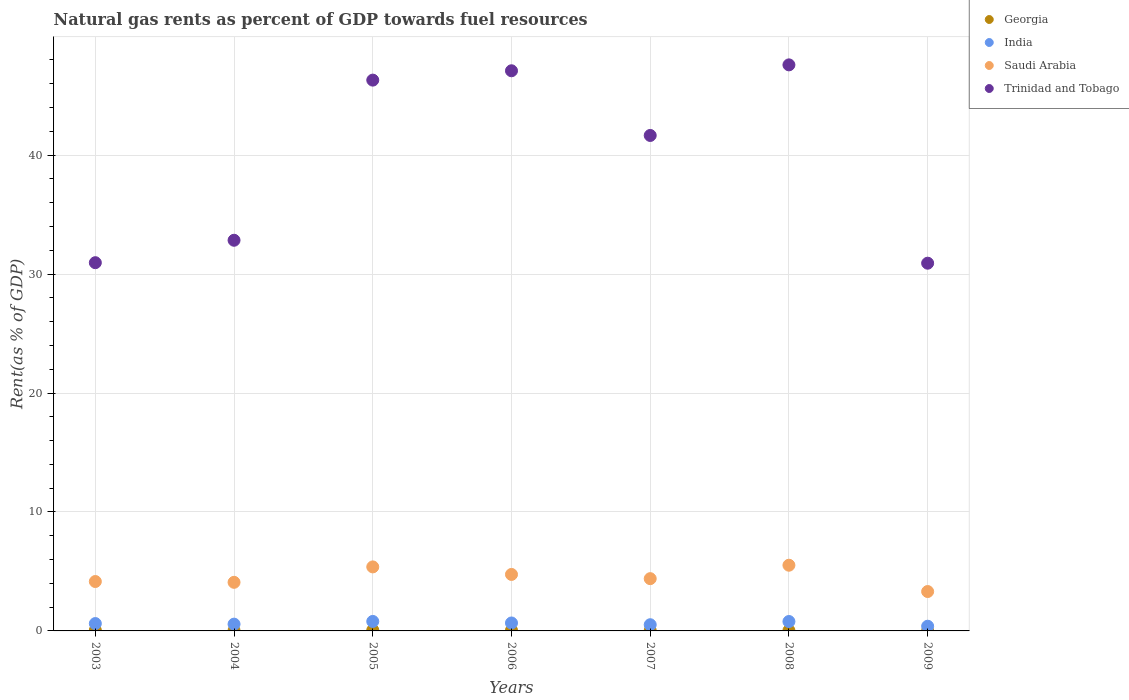Is the number of dotlines equal to the number of legend labels?
Offer a terse response. Yes. What is the matural gas rent in Georgia in 2008?
Provide a short and direct response. 0.03. Across all years, what is the maximum matural gas rent in Saudi Arabia?
Your answer should be compact. 5.52. Across all years, what is the minimum matural gas rent in Saudi Arabia?
Offer a very short reply. 3.31. In which year was the matural gas rent in Saudi Arabia minimum?
Give a very brief answer. 2009. What is the total matural gas rent in Georgia in the graph?
Your answer should be compact. 0.29. What is the difference between the matural gas rent in India in 2005 and that in 2009?
Your answer should be compact. 0.4. What is the difference between the matural gas rent in Georgia in 2006 and the matural gas rent in India in 2009?
Your response must be concise. -0.34. What is the average matural gas rent in Saudi Arabia per year?
Give a very brief answer. 4.51. In the year 2003, what is the difference between the matural gas rent in Saudi Arabia and matural gas rent in Trinidad and Tobago?
Offer a terse response. -26.8. In how many years, is the matural gas rent in Georgia greater than 18 %?
Make the answer very short. 0. What is the ratio of the matural gas rent in Saudi Arabia in 2003 to that in 2008?
Provide a short and direct response. 0.75. What is the difference between the highest and the second highest matural gas rent in Trinidad and Tobago?
Make the answer very short. 0.5. What is the difference between the highest and the lowest matural gas rent in Georgia?
Ensure brevity in your answer.  0.06. In how many years, is the matural gas rent in Georgia greater than the average matural gas rent in Georgia taken over all years?
Your answer should be very brief. 3. Is it the case that in every year, the sum of the matural gas rent in Saudi Arabia and matural gas rent in Trinidad and Tobago  is greater than the sum of matural gas rent in India and matural gas rent in Georgia?
Give a very brief answer. No. Does the matural gas rent in Saudi Arabia monotonically increase over the years?
Make the answer very short. No. Is the matural gas rent in Georgia strictly greater than the matural gas rent in Trinidad and Tobago over the years?
Give a very brief answer. No. Is the matural gas rent in Georgia strictly less than the matural gas rent in Trinidad and Tobago over the years?
Your answer should be compact. Yes. How many dotlines are there?
Ensure brevity in your answer.  4. What is the difference between two consecutive major ticks on the Y-axis?
Offer a very short reply. 10. Are the values on the major ticks of Y-axis written in scientific E-notation?
Your response must be concise. No. Does the graph contain grids?
Your response must be concise. Yes. How many legend labels are there?
Provide a short and direct response. 4. What is the title of the graph?
Ensure brevity in your answer.  Natural gas rents as percent of GDP towards fuel resources. What is the label or title of the Y-axis?
Offer a very short reply. Rent(as % of GDP). What is the Rent(as % of GDP) of Georgia in 2003?
Keep it short and to the point. 0.06. What is the Rent(as % of GDP) of India in 2003?
Provide a succinct answer. 0.62. What is the Rent(as % of GDP) in Saudi Arabia in 2003?
Give a very brief answer. 4.15. What is the Rent(as % of GDP) of Trinidad and Tobago in 2003?
Ensure brevity in your answer.  30.96. What is the Rent(as % of GDP) of Georgia in 2004?
Offer a very short reply. 0.03. What is the Rent(as % of GDP) of India in 2004?
Make the answer very short. 0.57. What is the Rent(as % of GDP) in Saudi Arabia in 2004?
Keep it short and to the point. 4.09. What is the Rent(as % of GDP) of Trinidad and Tobago in 2004?
Provide a short and direct response. 32.84. What is the Rent(as % of GDP) of Georgia in 2005?
Offer a terse response. 0.07. What is the Rent(as % of GDP) in India in 2005?
Your response must be concise. 0.8. What is the Rent(as % of GDP) in Saudi Arabia in 2005?
Keep it short and to the point. 5.38. What is the Rent(as % of GDP) in Trinidad and Tobago in 2005?
Provide a short and direct response. 46.3. What is the Rent(as % of GDP) of Georgia in 2006?
Ensure brevity in your answer.  0.05. What is the Rent(as % of GDP) of India in 2006?
Give a very brief answer. 0.67. What is the Rent(as % of GDP) of Saudi Arabia in 2006?
Your response must be concise. 4.75. What is the Rent(as % of GDP) in Trinidad and Tobago in 2006?
Your response must be concise. 47.09. What is the Rent(as % of GDP) of Georgia in 2007?
Your response must be concise. 0.03. What is the Rent(as % of GDP) in India in 2007?
Offer a very short reply. 0.52. What is the Rent(as % of GDP) in Saudi Arabia in 2007?
Give a very brief answer. 4.39. What is the Rent(as % of GDP) in Trinidad and Tobago in 2007?
Your answer should be very brief. 41.65. What is the Rent(as % of GDP) in Georgia in 2008?
Keep it short and to the point. 0.03. What is the Rent(as % of GDP) of India in 2008?
Make the answer very short. 0.79. What is the Rent(as % of GDP) in Saudi Arabia in 2008?
Provide a succinct answer. 5.52. What is the Rent(as % of GDP) in Trinidad and Tobago in 2008?
Make the answer very short. 47.58. What is the Rent(as % of GDP) of Georgia in 2009?
Your answer should be very brief. 0.01. What is the Rent(as % of GDP) of India in 2009?
Your answer should be very brief. 0.39. What is the Rent(as % of GDP) of Saudi Arabia in 2009?
Your response must be concise. 3.31. What is the Rent(as % of GDP) in Trinidad and Tobago in 2009?
Make the answer very short. 30.91. Across all years, what is the maximum Rent(as % of GDP) in Georgia?
Your response must be concise. 0.07. Across all years, what is the maximum Rent(as % of GDP) in India?
Make the answer very short. 0.8. Across all years, what is the maximum Rent(as % of GDP) in Saudi Arabia?
Keep it short and to the point. 5.52. Across all years, what is the maximum Rent(as % of GDP) in Trinidad and Tobago?
Your answer should be very brief. 47.58. Across all years, what is the minimum Rent(as % of GDP) of Georgia?
Keep it short and to the point. 0.01. Across all years, what is the minimum Rent(as % of GDP) of India?
Make the answer very short. 0.39. Across all years, what is the minimum Rent(as % of GDP) in Saudi Arabia?
Your answer should be compact. 3.31. Across all years, what is the minimum Rent(as % of GDP) in Trinidad and Tobago?
Ensure brevity in your answer.  30.91. What is the total Rent(as % of GDP) in Georgia in the graph?
Your answer should be compact. 0.29. What is the total Rent(as % of GDP) of India in the graph?
Ensure brevity in your answer.  4.36. What is the total Rent(as % of GDP) in Saudi Arabia in the graph?
Make the answer very short. 31.6. What is the total Rent(as % of GDP) in Trinidad and Tobago in the graph?
Keep it short and to the point. 277.33. What is the difference between the Rent(as % of GDP) of Georgia in 2003 and that in 2004?
Offer a terse response. 0.03. What is the difference between the Rent(as % of GDP) in India in 2003 and that in 2004?
Give a very brief answer. 0.05. What is the difference between the Rent(as % of GDP) in Saudi Arabia in 2003 and that in 2004?
Your answer should be very brief. 0.07. What is the difference between the Rent(as % of GDP) in Trinidad and Tobago in 2003 and that in 2004?
Provide a short and direct response. -1.89. What is the difference between the Rent(as % of GDP) in Georgia in 2003 and that in 2005?
Give a very brief answer. -0.01. What is the difference between the Rent(as % of GDP) of India in 2003 and that in 2005?
Your answer should be compact. -0.18. What is the difference between the Rent(as % of GDP) of Saudi Arabia in 2003 and that in 2005?
Offer a terse response. -1.23. What is the difference between the Rent(as % of GDP) in Trinidad and Tobago in 2003 and that in 2005?
Offer a terse response. -15.35. What is the difference between the Rent(as % of GDP) of Georgia in 2003 and that in 2006?
Provide a succinct answer. 0.01. What is the difference between the Rent(as % of GDP) of India in 2003 and that in 2006?
Give a very brief answer. -0.05. What is the difference between the Rent(as % of GDP) of Saudi Arabia in 2003 and that in 2006?
Offer a very short reply. -0.59. What is the difference between the Rent(as % of GDP) of Trinidad and Tobago in 2003 and that in 2006?
Offer a very short reply. -16.13. What is the difference between the Rent(as % of GDP) in Georgia in 2003 and that in 2007?
Your answer should be compact. 0.03. What is the difference between the Rent(as % of GDP) in India in 2003 and that in 2007?
Offer a very short reply. 0.1. What is the difference between the Rent(as % of GDP) in Saudi Arabia in 2003 and that in 2007?
Your response must be concise. -0.24. What is the difference between the Rent(as % of GDP) of Trinidad and Tobago in 2003 and that in 2007?
Make the answer very short. -10.7. What is the difference between the Rent(as % of GDP) of Georgia in 2003 and that in 2008?
Provide a succinct answer. 0.03. What is the difference between the Rent(as % of GDP) in India in 2003 and that in 2008?
Make the answer very short. -0.17. What is the difference between the Rent(as % of GDP) of Saudi Arabia in 2003 and that in 2008?
Ensure brevity in your answer.  -1.37. What is the difference between the Rent(as % of GDP) in Trinidad and Tobago in 2003 and that in 2008?
Give a very brief answer. -16.63. What is the difference between the Rent(as % of GDP) of Georgia in 2003 and that in 2009?
Provide a succinct answer. 0.05. What is the difference between the Rent(as % of GDP) of India in 2003 and that in 2009?
Offer a very short reply. 0.22. What is the difference between the Rent(as % of GDP) of Saudi Arabia in 2003 and that in 2009?
Provide a short and direct response. 0.84. What is the difference between the Rent(as % of GDP) of Trinidad and Tobago in 2003 and that in 2009?
Your response must be concise. 0.04. What is the difference between the Rent(as % of GDP) of Georgia in 2004 and that in 2005?
Offer a terse response. -0.03. What is the difference between the Rent(as % of GDP) in India in 2004 and that in 2005?
Your answer should be compact. -0.23. What is the difference between the Rent(as % of GDP) in Saudi Arabia in 2004 and that in 2005?
Your answer should be very brief. -1.3. What is the difference between the Rent(as % of GDP) of Trinidad and Tobago in 2004 and that in 2005?
Give a very brief answer. -13.46. What is the difference between the Rent(as % of GDP) of Georgia in 2004 and that in 2006?
Keep it short and to the point. -0.02. What is the difference between the Rent(as % of GDP) of India in 2004 and that in 2006?
Offer a terse response. -0.1. What is the difference between the Rent(as % of GDP) in Saudi Arabia in 2004 and that in 2006?
Your response must be concise. -0.66. What is the difference between the Rent(as % of GDP) in Trinidad and Tobago in 2004 and that in 2006?
Your response must be concise. -14.25. What is the difference between the Rent(as % of GDP) of Georgia in 2004 and that in 2007?
Keep it short and to the point. -0. What is the difference between the Rent(as % of GDP) of India in 2004 and that in 2007?
Make the answer very short. 0.05. What is the difference between the Rent(as % of GDP) in Saudi Arabia in 2004 and that in 2007?
Offer a terse response. -0.31. What is the difference between the Rent(as % of GDP) in Trinidad and Tobago in 2004 and that in 2007?
Keep it short and to the point. -8.81. What is the difference between the Rent(as % of GDP) of India in 2004 and that in 2008?
Keep it short and to the point. -0.22. What is the difference between the Rent(as % of GDP) of Saudi Arabia in 2004 and that in 2008?
Provide a succinct answer. -1.44. What is the difference between the Rent(as % of GDP) of Trinidad and Tobago in 2004 and that in 2008?
Give a very brief answer. -14.74. What is the difference between the Rent(as % of GDP) in Georgia in 2004 and that in 2009?
Give a very brief answer. 0.02. What is the difference between the Rent(as % of GDP) in India in 2004 and that in 2009?
Keep it short and to the point. 0.18. What is the difference between the Rent(as % of GDP) in Saudi Arabia in 2004 and that in 2009?
Your response must be concise. 0.77. What is the difference between the Rent(as % of GDP) in Trinidad and Tobago in 2004 and that in 2009?
Offer a very short reply. 1.93. What is the difference between the Rent(as % of GDP) of Georgia in 2005 and that in 2006?
Make the answer very short. 0.01. What is the difference between the Rent(as % of GDP) in India in 2005 and that in 2006?
Ensure brevity in your answer.  0.13. What is the difference between the Rent(as % of GDP) of Saudi Arabia in 2005 and that in 2006?
Offer a terse response. 0.63. What is the difference between the Rent(as % of GDP) in Trinidad and Tobago in 2005 and that in 2006?
Your response must be concise. -0.79. What is the difference between the Rent(as % of GDP) in Georgia in 2005 and that in 2007?
Ensure brevity in your answer.  0.03. What is the difference between the Rent(as % of GDP) of India in 2005 and that in 2007?
Keep it short and to the point. 0.28. What is the difference between the Rent(as % of GDP) in Saudi Arabia in 2005 and that in 2007?
Your response must be concise. 0.99. What is the difference between the Rent(as % of GDP) in Trinidad and Tobago in 2005 and that in 2007?
Offer a terse response. 4.65. What is the difference between the Rent(as % of GDP) of Georgia in 2005 and that in 2008?
Ensure brevity in your answer.  0.03. What is the difference between the Rent(as % of GDP) of India in 2005 and that in 2008?
Keep it short and to the point. 0.01. What is the difference between the Rent(as % of GDP) in Saudi Arabia in 2005 and that in 2008?
Provide a succinct answer. -0.14. What is the difference between the Rent(as % of GDP) of Trinidad and Tobago in 2005 and that in 2008?
Keep it short and to the point. -1.28. What is the difference between the Rent(as % of GDP) of Georgia in 2005 and that in 2009?
Keep it short and to the point. 0.06. What is the difference between the Rent(as % of GDP) of India in 2005 and that in 2009?
Ensure brevity in your answer.  0.4. What is the difference between the Rent(as % of GDP) of Saudi Arabia in 2005 and that in 2009?
Make the answer very short. 2.07. What is the difference between the Rent(as % of GDP) of Trinidad and Tobago in 2005 and that in 2009?
Offer a terse response. 15.39. What is the difference between the Rent(as % of GDP) in Georgia in 2006 and that in 2007?
Provide a succinct answer. 0.02. What is the difference between the Rent(as % of GDP) in India in 2006 and that in 2007?
Your response must be concise. 0.15. What is the difference between the Rent(as % of GDP) of Saudi Arabia in 2006 and that in 2007?
Offer a very short reply. 0.35. What is the difference between the Rent(as % of GDP) in Trinidad and Tobago in 2006 and that in 2007?
Your answer should be compact. 5.44. What is the difference between the Rent(as % of GDP) in Georgia in 2006 and that in 2008?
Your answer should be compact. 0.02. What is the difference between the Rent(as % of GDP) of India in 2006 and that in 2008?
Ensure brevity in your answer.  -0.12. What is the difference between the Rent(as % of GDP) in Saudi Arabia in 2006 and that in 2008?
Offer a very short reply. -0.77. What is the difference between the Rent(as % of GDP) of Trinidad and Tobago in 2006 and that in 2008?
Make the answer very short. -0.5. What is the difference between the Rent(as % of GDP) of Georgia in 2006 and that in 2009?
Make the answer very short. 0.04. What is the difference between the Rent(as % of GDP) in India in 2006 and that in 2009?
Your answer should be compact. 0.27. What is the difference between the Rent(as % of GDP) in Saudi Arabia in 2006 and that in 2009?
Give a very brief answer. 1.44. What is the difference between the Rent(as % of GDP) of Trinidad and Tobago in 2006 and that in 2009?
Make the answer very short. 16.18. What is the difference between the Rent(as % of GDP) of Georgia in 2007 and that in 2008?
Provide a short and direct response. 0. What is the difference between the Rent(as % of GDP) of India in 2007 and that in 2008?
Provide a succinct answer. -0.27. What is the difference between the Rent(as % of GDP) of Saudi Arabia in 2007 and that in 2008?
Offer a very short reply. -1.13. What is the difference between the Rent(as % of GDP) of Trinidad and Tobago in 2007 and that in 2008?
Provide a short and direct response. -5.93. What is the difference between the Rent(as % of GDP) of Georgia in 2007 and that in 2009?
Your response must be concise. 0.02. What is the difference between the Rent(as % of GDP) of India in 2007 and that in 2009?
Offer a very short reply. 0.13. What is the difference between the Rent(as % of GDP) in Saudi Arabia in 2007 and that in 2009?
Ensure brevity in your answer.  1.08. What is the difference between the Rent(as % of GDP) in Trinidad and Tobago in 2007 and that in 2009?
Your answer should be compact. 10.74. What is the difference between the Rent(as % of GDP) of Georgia in 2008 and that in 2009?
Offer a very short reply. 0.02. What is the difference between the Rent(as % of GDP) in India in 2008 and that in 2009?
Your response must be concise. 0.4. What is the difference between the Rent(as % of GDP) in Saudi Arabia in 2008 and that in 2009?
Offer a terse response. 2.21. What is the difference between the Rent(as % of GDP) of Trinidad and Tobago in 2008 and that in 2009?
Your answer should be very brief. 16.67. What is the difference between the Rent(as % of GDP) in Georgia in 2003 and the Rent(as % of GDP) in India in 2004?
Keep it short and to the point. -0.51. What is the difference between the Rent(as % of GDP) of Georgia in 2003 and the Rent(as % of GDP) of Saudi Arabia in 2004?
Ensure brevity in your answer.  -4.03. What is the difference between the Rent(as % of GDP) of Georgia in 2003 and the Rent(as % of GDP) of Trinidad and Tobago in 2004?
Your answer should be very brief. -32.78. What is the difference between the Rent(as % of GDP) of India in 2003 and the Rent(as % of GDP) of Saudi Arabia in 2004?
Your response must be concise. -3.47. What is the difference between the Rent(as % of GDP) of India in 2003 and the Rent(as % of GDP) of Trinidad and Tobago in 2004?
Your answer should be very brief. -32.22. What is the difference between the Rent(as % of GDP) of Saudi Arabia in 2003 and the Rent(as % of GDP) of Trinidad and Tobago in 2004?
Ensure brevity in your answer.  -28.69. What is the difference between the Rent(as % of GDP) of Georgia in 2003 and the Rent(as % of GDP) of India in 2005?
Keep it short and to the point. -0.74. What is the difference between the Rent(as % of GDP) in Georgia in 2003 and the Rent(as % of GDP) in Saudi Arabia in 2005?
Your answer should be compact. -5.32. What is the difference between the Rent(as % of GDP) of Georgia in 2003 and the Rent(as % of GDP) of Trinidad and Tobago in 2005?
Your answer should be compact. -46.24. What is the difference between the Rent(as % of GDP) in India in 2003 and the Rent(as % of GDP) in Saudi Arabia in 2005?
Offer a terse response. -4.76. What is the difference between the Rent(as % of GDP) of India in 2003 and the Rent(as % of GDP) of Trinidad and Tobago in 2005?
Your answer should be compact. -45.68. What is the difference between the Rent(as % of GDP) in Saudi Arabia in 2003 and the Rent(as % of GDP) in Trinidad and Tobago in 2005?
Give a very brief answer. -42.15. What is the difference between the Rent(as % of GDP) of Georgia in 2003 and the Rent(as % of GDP) of India in 2006?
Give a very brief answer. -0.61. What is the difference between the Rent(as % of GDP) of Georgia in 2003 and the Rent(as % of GDP) of Saudi Arabia in 2006?
Provide a short and direct response. -4.69. What is the difference between the Rent(as % of GDP) in Georgia in 2003 and the Rent(as % of GDP) in Trinidad and Tobago in 2006?
Your response must be concise. -47.03. What is the difference between the Rent(as % of GDP) in India in 2003 and the Rent(as % of GDP) in Saudi Arabia in 2006?
Make the answer very short. -4.13. What is the difference between the Rent(as % of GDP) of India in 2003 and the Rent(as % of GDP) of Trinidad and Tobago in 2006?
Your answer should be compact. -46.47. What is the difference between the Rent(as % of GDP) in Saudi Arabia in 2003 and the Rent(as % of GDP) in Trinidad and Tobago in 2006?
Your response must be concise. -42.93. What is the difference between the Rent(as % of GDP) of Georgia in 2003 and the Rent(as % of GDP) of India in 2007?
Make the answer very short. -0.46. What is the difference between the Rent(as % of GDP) in Georgia in 2003 and the Rent(as % of GDP) in Saudi Arabia in 2007?
Your response must be concise. -4.33. What is the difference between the Rent(as % of GDP) in Georgia in 2003 and the Rent(as % of GDP) in Trinidad and Tobago in 2007?
Give a very brief answer. -41.59. What is the difference between the Rent(as % of GDP) in India in 2003 and the Rent(as % of GDP) in Saudi Arabia in 2007?
Offer a very short reply. -3.78. What is the difference between the Rent(as % of GDP) in India in 2003 and the Rent(as % of GDP) in Trinidad and Tobago in 2007?
Make the answer very short. -41.03. What is the difference between the Rent(as % of GDP) in Saudi Arabia in 2003 and the Rent(as % of GDP) in Trinidad and Tobago in 2007?
Keep it short and to the point. -37.5. What is the difference between the Rent(as % of GDP) of Georgia in 2003 and the Rent(as % of GDP) of India in 2008?
Provide a succinct answer. -0.73. What is the difference between the Rent(as % of GDP) of Georgia in 2003 and the Rent(as % of GDP) of Saudi Arabia in 2008?
Your answer should be very brief. -5.46. What is the difference between the Rent(as % of GDP) in Georgia in 2003 and the Rent(as % of GDP) in Trinidad and Tobago in 2008?
Your answer should be compact. -47.52. What is the difference between the Rent(as % of GDP) of India in 2003 and the Rent(as % of GDP) of Saudi Arabia in 2008?
Provide a succinct answer. -4.9. What is the difference between the Rent(as % of GDP) of India in 2003 and the Rent(as % of GDP) of Trinidad and Tobago in 2008?
Your answer should be compact. -46.97. What is the difference between the Rent(as % of GDP) in Saudi Arabia in 2003 and the Rent(as % of GDP) in Trinidad and Tobago in 2008?
Ensure brevity in your answer.  -43.43. What is the difference between the Rent(as % of GDP) in Georgia in 2003 and the Rent(as % of GDP) in India in 2009?
Offer a terse response. -0.33. What is the difference between the Rent(as % of GDP) of Georgia in 2003 and the Rent(as % of GDP) of Saudi Arabia in 2009?
Offer a very short reply. -3.25. What is the difference between the Rent(as % of GDP) in Georgia in 2003 and the Rent(as % of GDP) in Trinidad and Tobago in 2009?
Make the answer very short. -30.85. What is the difference between the Rent(as % of GDP) of India in 2003 and the Rent(as % of GDP) of Saudi Arabia in 2009?
Provide a short and direct response. -2.69. What is the difference between the Rent(as % of GDP) of India in 2003 and the Rent(as % of GDP) of Trinidad and Tobago in 2009?
Your answer should be very brief. -30.29. What is the difference between the Rent(as % of GDP) in Saudi Arabia in 2003 and the Rent(as % of GDP) in Trinidad and Tobago in 2009?
Provide a succinct answer. -26.76. What is the difference between the Rent(as % of GDP) of Georgia in 2004 and the Rent(as % of GDP) of India in 2005?
Your answer should be compact. -0.77. What is the difference between the Rent(as % of GDP) of Georgia in 2004 and the Rent(as % of GDP) of Saudi Arabia in 2005?
Make the answer very short. -5.35. What is the difference between the Rent(as % of GDP) of Georgia in 2004 and the Rent(as % of GDP) of Trinidad and Tobago in 2005?
Your answer should be compact. -46.27. What is the difference between the Rent(as % of GDP) in India in 2004 and the Rent(as % of GDP) in Saudi Arabia in 2005?
Give a very brief answer. -4.81. What is the difference between the Rent(as % of GDP) in India in 2004 and the Rent(as % of GDP) in Trinidad and Tobago in 2005?
Offer a terse response. -45.73. What is the difference between the Rent(as % of GDP) of Saudi Arabia in 2004 and the Rent(as % of GDP) of Trinidad and Tobago in 2005?
Make the answer very short. -42.22. What is the difference between the Rent(as % of GDP) in Georgia in 2004 and the Rent(as % of GDP) in India in 2006?
Ensure brevity in your answer.  -0.64. What is the difference between the Rent(as % of GDP) of Georgia in 2004 and the Rent(as % of GDP) of Saudi Arabia in 2006?
Your answer should be compact. -4.72. What is the difference between the Rent(as % of GDP) in Georgia in 2004 and the Rent(as % of GDP) in Trinidad and Tobago in 2006?
Your answer should be compact. -47.06. What is the difference between the Rent(as % of GDP) of India in 2004 and the Rent(as % of GDP) of Saudi Arabia in 2006?
Your response must be concise. -4.18. What is the difference between the Rent(as % of GDP) of India in 2004 and the Rent(as % of GDP) of Trinidad and Tobago in 2006?
Provide a succinct answer. -46.52. What is the difference between the Rent(as % of GDP) in Saudi Arabia in 2004 and the Rent(as % of GDP) in Trinidad and Tobago in 2006?
Make the answer very short. -43. What is the difference between the Rent(as % of GDP) of Georgia in 2004 and the Rent(as % of GDP) of India in 2007?
Offer a terse response. -0.49. What is the difference between the Rent(as % of GDP) of Georgia in 2004 and the Rent(as % of GDP) of Saudi Arabia in 2007?
Your answer should be very brief. -4.36. What is the difference between the Rent(as % of GDP) of Georgia in 2004 and the Rent(as % of GDP) of Trinidad and Tobago in 2007?
Keep it short and to the point. -41.62. What is the difference between the Rent(as % of GDP) in India in 2004 and the Rent(as % of GDP) in Saudi Arabia in 2007?
Ensure brevity in your answer.  -3.82. What is the difference between the Rent(as % of GDP) of India in 2004 and the Rent(as % of GDP) of Trinidad and Tobago in 2007?
Keep it short and to the point. -41.08. What is the difference between the Rent(as % of GDP) in Saudi Arabia in 2004 and the Rent(as % of GDP) in Trinidad and Tobago in 2007?
Offer a terse response. -37.57. What is the difference between the Rent(as % of GDP) in Georgia in 2004 and the Rent(as % of GDP) in India in 2008?
Offer a terse response. -0.76. What is the difference between the Rent(as % of GDP) in Georgia in 2004 and the Rent(as % of GDP) in Saudi Arabia in 2008?
Ensure brevity in your answer.  -5.49. What is the difference between the Rent(as % of GDP) of Georgia in 2004 and the Rent(as % of GDP) of Trinidad and Tobago in 2008?
Make the answer very short. -47.55. What is the difference between the Rent(as % of GDP) in India in 2004 and the Rent(as % of GDP) in Saudi Arabia in 2008?
Provide a short and direct response. -4.95. What is the difference between the Rent(as % of GDP) in India in 2004 and the Rent(as % of GDP) in Trinidad and Tobago in 2008?
Provide a short and direct response. -47.01. What is the difference between the Rent(as % of GDP) of Saudi Arabia in 2004 and the Rent(as % of GDP) of Trinidad and Tobago in 2008?
Provide a short and direct response. -43.5. What is the difference between the Rent(as % of GDP) of Georgia in 2004 and the Rent(as % of GDP) of India in 2009?
Keep it short and to the point. -0.36. What is the difference between the Rent(as % of GDP) in Georgia in 2004 and the Rent(as % of GDP) in Saudi Arabia in 2009?
Offer a very short reply. -3.28. What is the difference between the Rent(as % of GDP) in Georgia in 2004 and the Rent(as % of GDP) in Trinidad and Tobago in 2009?
Provide a succinct answer. -30.88. What is the difference between the Rent(as % of GDP) in India in 2004 and the Rent(as % of GDP) in Saudi Arabia in 2009?
Provide a succinct answer. -2.74. What is the difference between the Rent(as % of GDP) of India in 2004 and the Rent(as % of GDP) of Trinidad and Tobago in 2009?
Keep it short and to the point. -30.34. What is the difference between the Rent(as % of GDP) in Saudi Arabia in 2004 and the Rent(as % of GDP) in Trinidad and Tobago in 2009?
Provide a short and direct response. -26.83. What is the difference between the Rent(as % of GDP) in Georgia in 2005 and the Rent(as % of GDP) in India in 2006?
Your response must be concise. -0.6. What is the difference between the Rent(as % of GDP) in Georgia in 2005 and the Rent(as % of GDP) in Saudi Arabia in 2006?
Your answer should be very brief. -4.68. What is the difference between the Rent(as % of GDP) in Georgia in 2005 and the Rent(as % of GDP) in Trinidad and Tobago in 2006?
Provide a short and direct response. -47.02. What is the difference between the Rent(as % of GDP) of India in 2005 and the Rent(as % of GDP) of Saudi Arabia in 2006?
Your answer should be very brief. -3.95. What is the difference between the Rent(as % of GDP) of India in 2005 and the Rent(as % of GDP) of Trinidad and Tobago in 2006?
Make the answer very short. -46.29. What is the difference between the Rent(as % of GDP) in Saudi Arabia in 2005 and the Rent(as % of GDP) in Trinidad and Tobago in 2006?
Your response must be concise. -41.71. What is the difference between the Rent(as % of GDP) of Georgia in 2005 and the Rent(as % of GDP) of India in 2007?
Make the answer very short. -0.46. What is the difference between the Rent(as % of GDP) of Georgia in 2005 and the Rent(as % of GDP) of Saudi Arabia in 2007?
Keep it short and to the point. -4.33. What is the difference between the Rent(as % of GDP) of Georgia in 2005 and the Rent(as % of GDP) of Trinidad and Tobago in 2007?
Keep it short and to the point. -41.59. What is the difference between the Rent(as % of GDP) in India in 2005 and the Rent(as % of GDP) in Saudi Arabia in 2007?
Your response must be concise. -3.6. What is the difference between the Rent(as % of GDP) of India in 2005 and the Rent(as % of GDP) of Trinidad and Tobago in 2007?
Provide a short and direct response. -40.85. What is the difference between the Rent(as % of GDP) in Saudi Arabia in 2005 and the Rent(as % of GDP) in Trinidad and Tobago in 2007?
Offer a very short reply. -36.27. What is the difference between the Rent(as % of GDP) in Georgia in 2005 and the Rent(as % of GDP) in India in 2008?
Your response must be concise. -0.73. What is the difference between the Rent(as % of GDP) of Georgia in 2005 and the Rent(as % of GDP) of Saudi Arabia in 2008?
Keep it short and to the point. -5.46. What is the difference between the Rent(as % of GDP) of Georgia in 2005 and the Rent(as % of GDP) of Trinidad and Tobago in 2008?
Your answer should be very brief. -47.52. What is the difference between the Rent(as % of GDP) of India in 2005 and the Rent(as % of GDP) of Saudi Arabia in 2008?
Give a very brief answer. -4.73. What is the difference between the Rent(as % of GDP) in India in 2005 and the Rent(as % of GDP) in Trinidad and Tobago in 2008?
Ensure brevity in your answer.  -46.79. What is the difference between the Rent(as % of GDP) of Saudi Arabia in 2005 and the Rent(as % of GDP) of Trinidad and Tobago in 2008?
Provide a succinct answer. -42.2. What is the difference between the Rent(as % of GDP) in Georgia in 2005 and the Rent(as % of GDP) in India in 2009?
Provide a succinct answer. -0.33. What is the difference between the Rent(as % of GDP) in Georgia in 2005 and the Rent(as % of GDP) in Saudi Arabia in 2009?
Give a very brief answer. -3.25. What is the difference between the Rent(as % of GDP) in Georgia in 2005 and the Rent(as % of GDP) in Trinidad and Tobago in 2009?
Offer a terse response. -30.85. What is the difference between the Rent(as % of GDP) of India in 2005 and the Rent(as % of GDP) of Saudi Arabia in 2009?
Your response must be concise. -2.51. What is the difference between the Rent(as % of GDP) of India in 2005 and the Rent(as % of GDP) of Trinidad and Tobago in 2009?
Provide a short and direct response. -30.11. What is the difference between the Rent(as % of GDP) of Saudi Arabia in 2005 and the Rent(as % of GDP) of Trinidad and Tobago in 2009?
Your answer should be compact. -25.53. What is the difference between the Rent(as % of GDP) of Georgia in 2006 and the Rent(as % of GDP) of India in 2007?
Your answer should be compact. -0.47. What is the difference between the Rent(as % of GDP) in Georgia in 2006 and the Rent(as % of GDP) in Saudi Arabia in 2007?
Ensure brevity in your answer.  -4.34. What is the difference between the Rent(as % of GDP) in Georgia in 2006 and the Rent(as % of GDP) in Trinidad and Tobago in 2007?
Your answer should be compact. -41.6. What is the difference between the Rent(as % of GDP) of India in 2006 and the Rent(as % of GDP) of Saudi Arabia in 2007?
Provide a succinct answer. -3.73. What is the difference between the Rent(as % of GDP) of India in 2006 and the Rent(as % of GDP) of Trinidad and Tobago in 2007?
Your answer should be compact. -40.98. What is the difference between the Rent(as % of GDP) of Saudi Arabia in 2006 and the Rent(as % of GDP) of Trinidad and Tobago in 2007?
Keep it short and to the point. -36.9. What is the difference between the Rent(as % of GDP) of Georgia in 2006 and the Rent(as % of GDP) of India in 2008?
Ensure brevity in your answer.  -0.74. What is the difference between the Rent(as % of GDP) of Georgia in 2006 and the Rent(as % of GDP) of Saudi Arabia in 2008?
Offer a very short reply. -5.47. What is the difference between the Rent(as % of GDP) of Georgia in 2006 and the Rent(as % of GDP) of Trinidad and Tobago in 2008?
Offer a very short reply. -47.53. What is the difference between the Rent(as % of GDP) in India in 2006 and the Rent(as % of GDP) in Saudi Arabia in 2008?
Your response must be concise. -4.86. What is the difference between the Rent(as % of GDP) of India in 2006 and the Rent(as % of GDP) of Trinidad and Tobago in 2008?
Offer a terse response. -46.92. What is the difference between the Rent(as % of GDP) of Saudi Arabia in 2006 and the Rent(as % of GDP) of Trinidad and Tobago in 2008?
Your answer should be compact. -42.84. What is the difference between the Rent(as % of GDP) in Georgia in 2006 and the Rent(as % of GDP) in India in 2009?
Provide a short and direct response. -0.34. What is the difference between the Rent(as % of GDP) of Georgia in 2006 and the Rent(as % of GDP) of Saudi Arabia in 2009?
Provide a succinct answer. -3.26. What is the difference between the Rent(as % of GDP) of Georgia in 2006 and the Rent(as % of GDP) of Trinidad and Tobago in 2009?
Make the answer very short. -30.86. What is the difference between the Rent(as % of GDP) of India in 2006 and the Rent(as % of GDP) of Saudi Arabia in 2009?
Offer a terse response. -2.64. What is the difference between the Rent(as % of GDP) of India in 2006 and the Rent(as % of GDP) of Trinidad and Tobago in 2009?
Provide a short and direct response. -30.25. What is the difference between the Rent(as % of GDP) of Saudi Arabia in 2006 and the Rent(as % of GDP) of Trinidad and Tobago in 2009?
Your response must be concise. -26.16. What is the difference between the Rent(as % of GDP) in Georgia in 2007 and the Rent(as % of GDP) in India in 2008?
Your response must be concise. -0.76. What is the difference between the Rent(as % of GDP) in Georgia in 2007 and the Rent(as % of GDP) in Saudi Arabia in 2008?
Make the answer very short. -5.49. What is the difference between the Rent(as % of GDP) in Georgia in 2007 and the Rent(as % of GDP) in Trinidad and Tobago in 2008?
Offer a terse response. -47.55. What is the difference between the Rent(as % of GDP) in India in 2007 and the Rent(as % of GDP) in Saudi Arabia in 2008?
Provide a succinct answer. -5. What is the difference between the Rent(as % of GDP) of India in 2007 and the Rent(as % of GDP) of Trinidad and Tobago in 2008?
Your response must be concise. -47.06. What is the difference between the Rent(as % of GDP) in Saudi Arabia in 2007 and the Rent(as % of GDP) in Trinidad and Tobago in 2008?
Your answer should be very brief. -43.19. What is the difference between the Rent(as % of GDP) of Georgia in 2007 and the Rent(as % of GDP) of India in 2009?
Keep it short and to the point. -0.36. What is the difference between the Rent(as % of GDP) in Georgia in 2007 and the Rent(as % of GDP) in Saudi Arabia in 2009?
Your response must be concise. -3.28. What is the difference between the Rent(as % of GDP) of Georgia in 2007 and the Rent(as % of GDP) of Trinidad and Tobago in 2009?
Provide a short and direct response. -30.88. What is the difference between the Rent(as % of GDP) of India in 2007 and the Rent(as % of GDP) of Saudi Arabia in 2009?
Your response must be concise. -2.79. What is the difference between the Rent(as % of GDP) of India in 2007 and the Rent(as % of GDP) of Trinidad and Tobago in 2009?
Your response must be concise. -30.39. What is the difference between the Rent(as % of GDP) of Saudi Arabia in 2007 and the Rent(as % of GDP) of Trinidad and Tobago in 2009?
Provide a short and direct response. -26.52. What is the difference between the Rent(as % of GDP) in Georgia in 2008 and the Rent(as % of GDP) in India in 2009?
Your answer should be compact. -0.36. What is the difference between the Rent(as % of GDP) of Georgia in 2008 and the Rent(as % of GDP) of Saudi Arabia in 2009?
Make the answer very short. -3.28. What is the difference between the Rent(as % of GDP) of Georgia in 2008 and the Rent(as % of GDP) of Trinidad and Tobago in 2009?
Make the answer very short. -30.88. What is the difference between the Rent(as % of GDP) of India in 2008 and the Rent(as % of GDP) of Saudi Arabia in 2009?
Keep it short and to the point. -2.52. What is the difference between the Rent(as % of GDP) in India in 2008 and the Rent(as % of GDP) in Trinidad and Tobago in 2009?
Offer a very short reply. -30.12. What is the difference between the Rent(as % of GDP) of Saudi Arabia in 2008 and the Rent(as % of GDP) of Trinidad and Tobago in 2009?
Ensure brevity in your answer.  -25.39. What is the average Rent(as % of GDP) of Georgia per year?
Provide a short and direct response. 0.04. What is the average Rent(as % of GDP) in India per year?
Provide a succinct answer. 0.62. What is the average Rent(as % of GDP) of Saudi Arabia per year?
Offer a terse response. 4.51. What is the average Rent(as % of GDP) of Trinidad and Tobago per year?
Offer a terse response. 39.62. In the year 2003, what is the difference between the Rent(as % of GDP) of Georgia and Rent(as % of GDP) of India?
Make the answer very short. -0.56. In the year 2003, what is the difference between the Rent(as % of GDP) in Georgia and Rent(as % of GDP) in Saudi Arabia?
Make the answer very short. -4.09. In the year 2003, what is the difference between the Rent(as % of GDP) in Georgia and Rent(as % of GDP) in Trinidad and Tobago?
Your response must be concise. -30.9. In the year 2003, what is the difference between the Rent(as % of GDP) in India and Rent(as % of GDP) in Saudi Arabia?
Offer a very short reply. -3.54. In the year 2003, what is the difference between the Rent(as % of GDP) in India and Rent(as % of GDP) in Trinidad and Tobago?
Offer a terse response. -30.34. In the year 2003, what is the difference between the Rent(as % of GDP) in Saudi Arabia and Rent(as % of GDP) in Trinidad and Tobago?
Your answer should be compact. -26.8. In the year 2004, what is the difference between the Rent(as % of GDP) in Georgia and Rent(as % of GDP) in India?
Your response must be concise. -0.54. In the year 2004, what is the difference between the Rent(as % of GDP) of Georgia and Rent(as % of GDP) of Saudi Arabia?
Your answer should be very brief. -4.05. In the year 2004, what is the difference between the Rent(as % of GDP) in Georgia and Rent(as % of GDP) in Trinidad and Tobago?
Your answer should be very brief. -32.81. In the year 2004, what is the difference between the Rent(as % of GDP) in India and Rent(as % of GDP) in Saudi Arabia?
Keep it short and to the point. -3.51. In the year 2004, what is the difference between the Rent(as % of GDP) in India and Rent(as % of GDP) in Trinidad and Tobago?
Make the answer very short. -32.27. In the year 2004, what is the difference between the Rent(as % of GDP) of Saudi Arabia and Rent(as % of GDP) of Trinidad and Tobago?
Provide a succinct answer. -28.76. In the year 2005, what is the difference between the Rent(as % of GDP) in Georgia and Rent(as % of GDP) in India?
Offer a terse response. -0.73. In the year 2005, what is the difference between the Rent(as % of GDP) of Georgia and Rent(as % of GDP) of Saudi Arabia?
Ensure brevity in your answer.  -5.32. In the year 2005, what is the difference between the Rent(as % of GDP) in Georgia and Rent(as % of GDP) in Trinidad and Tobago?
Your response must be concise. -46.24. In the year 2005, what is the difference between the Rent(as % of GDP) in India and Rent(as % of GDP) in Saudi Arabia?
Provide a short and direct response. -4.58. In the year 2005, what is the difference between the Rent(as % of GDP) of India and Rent(as % of GDP) of Trinidad and Tobago?
Provide a short and direct response. -45.5. In the year 2005, what is the difference between the Rent(as % of GDP) in Saudi Arabia and Rent(as % of GDP) in Trinidad and Tobago?
Keep it short and to the point. -40.92. In the year 2006, what is the difference between the Rent(as % of GDP) of Georgia and Rent(as % of GDP) of India?
Your response must be concise. -0.62. In the year 2006, what is the difference between the Rent(as % of GDP) in Georgia and Rent(as % of GDP) in Saudi Arabia?
Give a very brief answer. -4.7. In the year 2006, what is the difference between the Rent(as % of GDP) in Georgia and Rent(as % of GDP) in Trinidad and Tobago?
Make the answer very short. -47.04. In the year 2006, what is the difference between the Rent(as % of GDP) in India and Rent(as % of GDP) in Saudi Arabia?
Your answer should be very brief. -4.08. In the year 2006, what is the difference between the Rent(as % of GDP) of India and Rent(as % of GDP) of Trinidad and Tobago?
Your answer should be very brief. -46.42. In the year 2006, what is the difference between the Rent(as % of GDP) of Saudi Arabia and Rent(as % of GDP) of Trinidad and Tobago?
Your answer should be very brief. -42.34. In the year 2007, what is the difference between the Rent(as % of GDP) in Georgia and Rent(as % of GDP) in India?
Keep it short and to the point. -0.49. In the year 2007, what is the difference between the Rent(as % of GDP) of Georgia and Rent(as % of GDP) of Saudi Arabia?
Provide a succinct answer. -4.36. In the year 2007, what is the difference between the Rent(as % of GDP) in Georgia and Rent(as % of GDP) in Trinidad and Tobago?
Offer a terse response. -41.62. In the year 2007, what is the difference between the Rent(as % of GDP) in India and Rent(as % of GDP) in Saudi Arabia?
Provide a succinct answer. -3.87. In the year 2007, what is the difference between the Rent(as % of GDP) of India and Rent(as % of GDP) of Trinidad and Tobago?
Ensure brevity in your answer.  -41.13. In the year 2007, what is the difference between the Rent(as % of GDP) in Saudi Arabia and Rent(as % of GDP) in Trinidad and Tobago?
Give a very brief answer. -37.26. In the year 2008, what is the difference between the Rent(as % of GDP) of Georgia and Rent(as % of GDP) of India?
Provide a short and direct response. -0.76. In the year 2008, what is the difference between the Rent(as % of GDP) of Georgia and Rent(as % of GDP) of Saudi Arabia?
Offer a terse response. -5.49. In the year 2008, what is the difference between the Rent(as % of GDP) in Georgia and Rent(as % of GDP) in Trinidad and Tobago?
Make the answer very short. -47.55. In the year 2008, what is the difference between the Rent(as % of GDP) of India and Rent(as % of GDP) of Saudi Arabia?
Provide a succinct answer. -4.73. In the year 2008, what is the difference between the Rent(as % of GDP) of India and Rent(as % of GDP) of Trinidad and Tobago?
Your answer should be very brief. -46.79. In the year 2008, what is the difference between the Rent(as % of GDP) of Saudi Arabia and Rent(as % of GDP) of Trinidad and Tobago?
Keep it short and to the point. -42.06. In the year 2009, what is the difference between the Rent(as % of GDP) of Georgia and Rent(as % of GDP) of India?
Your response must be concise. -0.39. In the year 2009, what is the difference between the Rent(as % of GDP) of Georgia and Rent(as % of GDP) of Saudi Arabia?
Your answer should be compact. -3.3. In the year 2009, what is the difference between the Rent(as % of GDP) of Georgia and Rent(as % of GDP) of Trinidad and Tobago?
Your response must be concise. -30.9. In the year 2009, what is the difference between the Rent(as % of GDP) of India and Rent(as % of GDP) of Saudi Arabia?
Offer a terse response. -2.92. In the year 2009, what is the difference between the Rent(as % of GDP) in India and Rent(as % of GDP) in Trinidad and Tobago?
Your answer should be compact. -30.52. In the year 2009, what is the difference between the Rent(as % of GDP) of Saudi Arabia and Rent(as % of GDP) of Trinidad and Tobago?
Offer a very short reply. -27.6. What is the ratio of the Rent(as % of GDP) in Georgia in 2003 to that in 2004?
Keep it short and to the point. 1.82. What is the ratio of the Rent(as % of GDP) of India in 2003 to that in 2004?
Your answer should be compact. 1.08. What is the ratio of the Rent(as % of GDP) in Saudi Arabia in 2003 to that in 2004?
Your answer should be very brief. 1.02. What is the ratio of the Rent(as % of GDP) in Trinidad and Tobago in 2003 to that in 2004?
Make the answer very short. 0.94. What is the ratio of the Rent(as % of GDP) in Georgia in 2003 to that in 2005?
Provide a succinct answer. 0.92. What is the ratio of the Rent(as % of GDP) of India in 2003 to that in 2005?
Your answer should be very brief. 0.77. What is the ratio of the Rent(as % of GDP) in Saudi Arabia in 2003 to that in 2005?
Ensure brevity in your answer.  0.77. What is the ratio of the Rent(as % of GDP) of Trinidad and Tobago in 2003 to that in 2005?
Your answer should be compact. 0.67. What is the ratio of the Rent(as % of GDP) in Georgia in 2003 to that in 2006?
Your answer should be compact. 1.16. What is the ratio of the Rent(as % of GDP) of India in 2003 to that in 2006?
Your answer should be very brief. 0.93. What is the ratio of the Rent(as % of GDP) of Saudi Arabia in 2003 to that in 2006?
Provide a succinct answer. 0.87. What is the ratio of the Rent(as % of GDP) in Trinidad and Tobago in 2003 to that in 2006?
Offer a very short reply. 0.66. What is the ratio of the Rent(as % of GDP) of Georgia in 2003 to that in 2007?
Your response must be concise. 1.74. What is the ratio of the Rent(as % of GDP) in India in 2003 to that in 2007?
Your answer should be very brief. 1.19. What is the ratio of the Rent(as % of GDP) of Saudi Arabia in 2003 to that in 2007?
Ensure brevity in your answer.  0.95. What is the ratio of the Rent(as % of GDP) of Trinidad and Tobago in 2003 to that in 2007?
Offer a terse response. 0.74. What is the ratio of the Rent(as % of GDP) of Georgia in 2003 to that in 2008?
Provide a succinct answer. 1.85. What is the ratio of the Rent(as % of GDP) in India in 2003 to that in 2008?
Your answer should be compact. 0.78. What is the ratio of the Rent(as % of GDP) of Saudi Arabia in 2003 to that in 2008?
Ensure brevity in your answer.  0.75. What is the ratio of the Rent(as % of GDP) of Trinidad and Tobago in 2003 to that in 2008?
Offer a very short reply. 0.65. What is the ratio of the Rent(as % of GDP) of Georgia in 2003 to that in 2009?
Your answer should be very brief. 6.36. What is the ratio of the Rent(as % of GDP) of India in 2003 to that in 2009?
Ensure brevity in your answer.  1.57. What is the ratio of the Rent(as % of GDP) in Saudi Arabia in 2003 to that in 2009?
Keep it short and to the point. 1.25. What is the ratio of the Rent(as % of GDP) of Trinidad and Tobago in 2003 to that in 2009?
Your answer should be compact. 1. What is the ratio of the Rent(as % of GDP) of Georgia in 2004 to that in 2005?
Your answer should be very brief. 0.5. What is the ratio of the Rent(as % of GDP) in India in 2004 to that in 2005?
Keep it short and to the point. 0.71. What is the ratio of the Rent(as % of GDP) in Saudi Arabia in 2004 to that in 2005?
Make the answer very short. 0.76. What is the ratio of the Rent(as % of GDP) in Trinidad and Tobago in 2004 to that in 2005?
Make the answer very short. 0.71. What is the ratio of the Rent(as % of GDP) of Georgia in 2004 to that in 2006?
Offer a terse response. 0.63. What is the ratio of the Rent(as % of GDP) of India in 2004 to that in 2006?
Make the answer very short. 0.85. What is the ratio of the Rent(as % of GDP) in Saudi Arabia in 2004 to that in 2006?
Keep it short and to the point. 0.86. What is the ratio of the Rent(as % of GDP) in Trinidad and Tobago in 2004 to that in 2006?
Ensure brevity in your answer.  0.7. What is the ratio of the Rent(as % of GDP) in Georgia in 2004 to that in 2007?
Your answer should be compact. 0.96. What is the ratio of the Rent(as % of GDP) of India in 2004 to that in 2007?
Your response must be concise. 1.09. What is the ratio of the Rent(as % of GDP) of Saudi Arabia in 2004 to that in 2007?
Your answer should be compact. 0.93. What is the ratio of the Rent(as % of GDP) in Trinidad and Tobago in 2004 to that in 2007?
Provide a short and direct response. 0.79. What is the ratio of the Rent(as % of GDP) of Georgia in 2004 to that in 2008?
Offer a very short reply. 1.01. What is the ratio of the Rent(as % of GDP) in India in 2004 to that in 2008?
Your response must be concise. 0.72. What is the ratio of the Rent(as % of GDP) in Saudi Arabia in 2004 to that in 2008?
Provide a short and direct response. 0.74. What is the ratio of the Rent(as % of GDP) of Trinidad and Tobago in 2004 to that in 2008?
Your answer should be very brief. 0.69. What is the ratio of the Rent(as % of GDP) of Georgia in 2004 to that in 2009?
Your answer should be compact. 3.49. What is the ratio of the Rent(as % of GDP) in India in 2004 to that in 2009?
Make the answer very short. 1.44. What is the ratio of the Rent(as % of GDP) of Saudi Arabia in 2004 to that in 2009?
Make the answer very short. 1.23. What is the ratio of the Rent(as % of GDP) in Trinidad and Tobago in 2004 to that in 2009?
Offer a terse response. 1.06. What is the ratio of the Rent(as % of GDP) in Georgia in 2005 to that in 2006?
Provide a succinct answer. 1.26. What is the ratio of the Rent(as % of GDP) in India in 2005 to that in 2006?
Keep it short and to the point. 1.19. What is the ratio of the Rent(as % of GDP) in Saudi Arabia in 2005 to that in 2006?
Keep it short and to the point. 1.13. What is the ratio of the Rent(as % of GDP) of Trinidad and Tobago in 2005 to that in 2006?
Provide a succinct answer. 0.98. What is the ratio of the Rent(as % of GDP) in Georgia in 2005 to that in 2007?
Give a very brief answer. 1.9. What is the ratio of the Rent(as % of GDP) of India in 2005 to that in 2007?
Ensure brevity in your answer.  1.53. What is the ratio of the Rent(as % of GDP) of Saudi Arabia in 2005 to that in 2007?
Offer a very short reply. 1.22. What is the ratio of the Rent(as % of GDP) in Trinidad and Tobago in 2005 to that in 2007?
Your answer should be compact. 1.11. What is the ratio of the Rent(as % of GDP) in Georgia in 2005 to that in 2008?
Provide a succinct answer. 2.01. What is the ratio of the Rent(as % of GDP) of India in 2005 to that in 2008?
Give a very brief answer. 1.01. What is the ratio of the Rent(as % of GDP) of Saudi Arabia in 2005 to that in 2008?
Your response must be concise. 0.97. What is the ratio of the Rent(as % of GDP) in Trinidad and Tobago in 2005 to that in 2008?
Make the answer very short. 0.97. What is the ratio of the Rent(as % of GDP) of Georgia in 2005 to that in 2009?
Your answer should be compact. 6.93. What is the ratio of the Rent(as % of GDP) in India in 2005 to that in 2009?
Ensure brevity in your answer.  2.02. What is the ratio of the Rent(as % of GDP) in Saudi Arabia in 2005 to that in 2009?
Provide a succinct answer. 1.63. What is the ratio of the Rent(as % of GDP) in Trinidad and Tobago in 2005 to that in 2009?
Ensure brevity in your answer.  1.5. What is the ratio of the Rent(as % of GDP) in Georgia in 2006 to that in 2007?
Keep it short and to the point. 1.51. What is the ratio of the Rent(as % of GDP) in India in 2006 to that in 2007?
Your response must be concise. 1.28. What is the ratio of the Rent(as % of GDP) of Saudi Arabia in 2006 to that in 2007?
Your answer should be compact. 1.08. What is the ratio of the Rent(as % of GDP) in Trinidad and Tobago in 2006 to that in 2007?
Provide a short and direct response. 1.13. What is the ratio of the Rent(as % of GDP) of Georgia in 2006 to that in 2008?
Offer a terse response. 1.6. What is the ratio of the Rent(as % of GDP) of India in 2006 to that in 2008?
Keep it short and to the point. 0.84. What is the ratio of the Rent(as % of GDP) in Saudi Arabia in 2006 to that in 2008?
Make the answer very short. 0.86. What is the ratio of the Rent(as % of GDP) of Trinidad and Tobago in 2006 to that in 2008?
Your answer should be compact. 0.99. What is the ratio of the Rent(as % of GDP) in Georgia in 2006 to that in 2009?
Offer a terse response. 5.5. What is the ratio of the Rent(as % of GDP) of India in 2006 to that in 2009?
Offer a terse response. 1.69. What is the ratio of the Rent(as % of GDP) of Saudi Arabia in 2006 to that in 2009?
Offer a terse response. 1.43. What is the ratio of the Rent(as % of GDP) of Trinidad and Tobago in 2006 to that in 2009?
Make the answer very short. 1.52. What is the ratio of the Rent(as % of GDP) in Georgia in 2007 to that in 2008?
Offer a terse response. 1.06. What is the ratio of the Rent(as % of GDP) in India in 2007 to that in 2008?
Your answer should be very brief. 0.66. What is the ratio of the Rent(as % of GDP) in Saudi Arabia in 2007 to that in 2008?
Your answer should be compact. 0.8. What is the ratio of the Rent(as % of GDP) of Trinidad and Tobago in 2007 to that in 2008?
Your answer should be compact. 0.88. What is the ratio of the Rent(as % of GDP) of Georgia in 2007 to that in 2009?
Provide a short and direct response. 3.65. What is the ratio of the Rent(as % of GDP) in India in 2007 to that in 2009?
Provide a short and direct response. 1.32. What is the ratio of the Rent(as % of GDP) of Saudi Arabia in 2007 to that in 2009?
Make the answer very short. 1.33. What is the ratio of the Rent(as % of GDP) in Trinidad and Tobago in 2007 to that in 2009?
Provide a succinct answer. 1.35. What is the ratio of the Rent(as % of GDP) of Georgia in 2008 to that in 2009?
Offer a very short reply. 3.44. What is the ratio of the Rent(as % of GDP) in India in 2008 to that in 2009?
Your answer should be compact. 2.01. What is the ratio of the Rent(as % of GDP) in Saudi Arabia in 2008 to that in 2009?
Offer a terse response. 1.67. What is the ratio of the Rent(as % of GDP) in Trinidad and Tobago in 2008 to that in 2009?
Your answer should be very brief. 1.54. What is the difference between the highest and the second highest Rent(as % of GDP) in Georgia?
Make the answer very short. 0.01. What is the difference between the highest and the second highest Rent(as % of GDP) in India?
Your answer should be compact. 0.01. What is the difference between the highest and the second highest Rent(as % of GDP) of Saudi Arabia?
Make the answer very short. 0.14. What is the difference between the highest and the second highest Rent(as % of GDP) in Trinidad and Tobago?
Ensure brevity in your answer.  0.5. What is the difference between the highest and the lowest Rent(as % of GDP) in Georgia?
Your answer should be compact. 0.06. What is the difference between the highest and the lowest Rent(as % of GDP) of India?
Provide a succinct answer. 0.4. What is the difference between the highest and the lowest Rent(as % of GDP) in Saudi Arabia?
Your answer should be compact. 2.21. What is the difference between the highest and the lowest Rent(as % of GDP) in Trinidad and Tobago?
Offer a terse response. 16.67. 